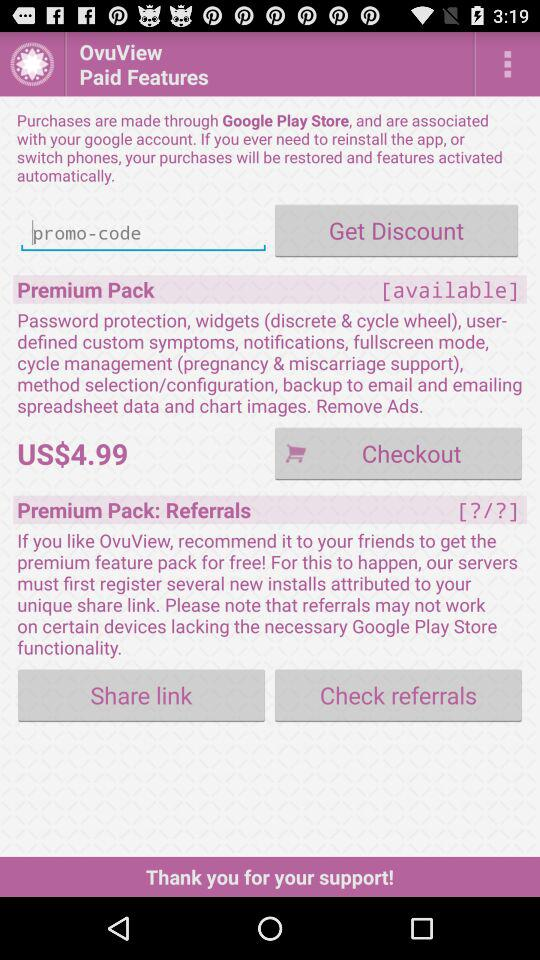Through what application can we purchase the paid features? You can purchase the paid features through the "Google Play Store". 